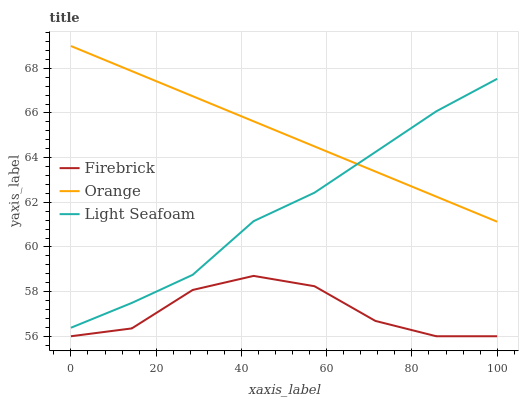Does Light Seafoam have the minimum area under the curve?
Answer yes or no. No. Does Light Seafoam have the maximum area under the curve?
Answer yes or no. No. Is Light Seafoam the smoothest?
Answer yes or no. No. Is Light Seafoam the roughest?
Answer yes or no. No. Does Light Seafoam have the lowest value?
Answer yes or no. No. Does Light Seafoam have the highest value?
Answer yes or no. No. Is Firebrick less than Orange?
Answer yes or no. Yes. Is Light Seafoam greater than Firebrick?
Answer yes or no. Yes. Does Firebrick intersect Orange?
Answer yes or no. No. 